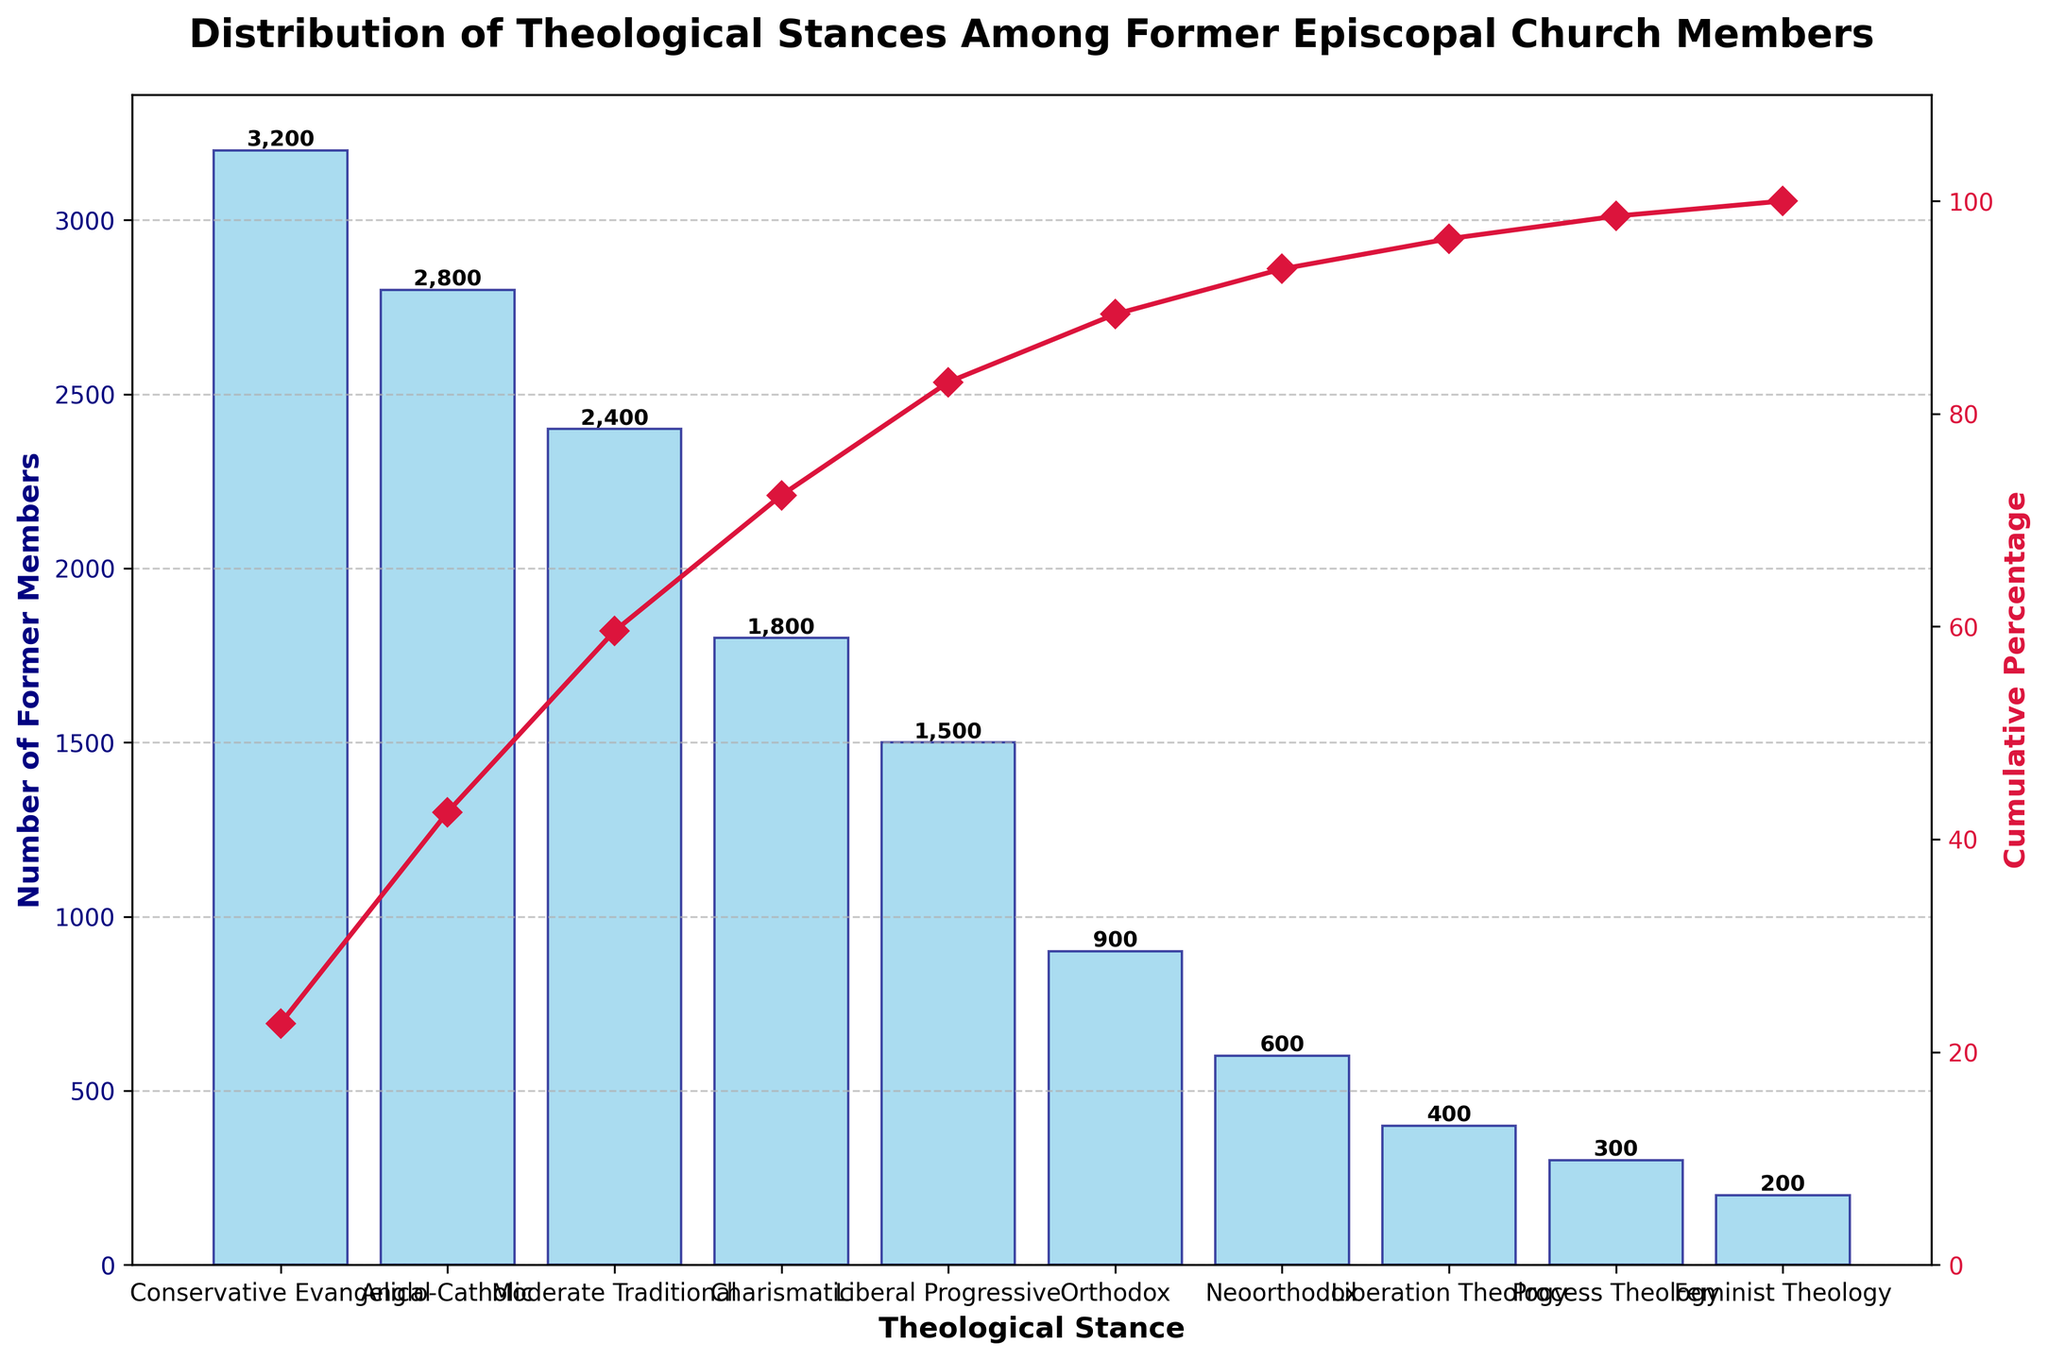What is the title of the figure? The title of the figure is prominently displayed at the top and summarizes the content of the chart. The title here is "Distribution of Theological Stances Among Former Episcopal Church Members."
Answer: Distribution of Theological Stances Among Former Episcopal Church Members What theological stance has the highest number of former members? The figure shows the theological stance categories on the x-axis and the number of former members on the y-axis. The bar corresponding to "Conservative Evangelical" is the tallest.
Answer: Conservative Evangelical How many former members fall under the Liberal Progressive stance? Identify the bar labeled "Liberal Progressive" on the x-axis and read off the value on the y-axis. The bar's height is 1500, indicating the number of former members.
Answer: 1500 Which theological stance comprises the smallest number of former members? Look at the shortest bar on the plot, which corresponds to the smallest value on the y-axis. The shortest bar is "Feminist Theology" with 200 members.
Answer: Feminist Theology What percentage of members are cumulatively covered by the three largest theological stances? The three largest stances are Conservative Evangelical (3200), Anglo-Catholic (2800), and Moderate Traditional (2400). Sum these values: 3200 + 2800 + 2400 = 8400. Calculate the total number of former members: 3200 + 2800 + 2400 + 1800 + 1500 + 900 + 600 + 400 + 300 + 200 = 14100. The percentage is (8400 / 14100) * 100% = 59.57%.
Answer: 59.57% How does the number of former Charismatic members compare to Conservative Evangelical members? Compare the height of the bars for "Charismatic" and "Conservative Evangelical." The former is 1800, while the latter is 3200. Conservative Evangelical has 3200 - 1800 = 1400 more members than Charismatic.
Answer: Conservative Evangelical has 1400 more What is the cumulative percentage after Anglo-Catholic in the distribution? Add the numbers for Conservative Evangelical (3200) and Anglo-Catholic (2800): 3200 + 2800 = 6000. Calculate the cumulative percentage: (6000 / 14100) * 100% ≈ 42.55%.
Answer: 42.55% Between Liberation Theology and Process Theology, which has more former members and by how many? Compare the bars for "Liberation Theology" and "Process Theology." Liberation Theology has 400 members, while Process Theology has 300. The difference is 400 - 300 = 100.
Answer: Liberation Theology by 100 members Which stance marks the cumulative percentage reaching the majority mark (over 50%)? Calculate cumulative percentages as you move down the sorted list: Conservative Evangelical (22.7%), Anglo-Catholic (42.55%), Moderate Traditional (59.57%). Moderate Traditional pushes the cumulative percentage over 50%.
Answer: Moderate Traditional 